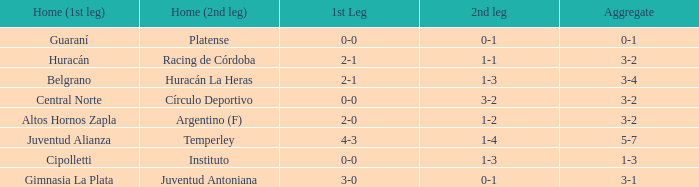Which team participated in the first leg at their home ground and ended with a combined score of 3-4? Belgrano. 